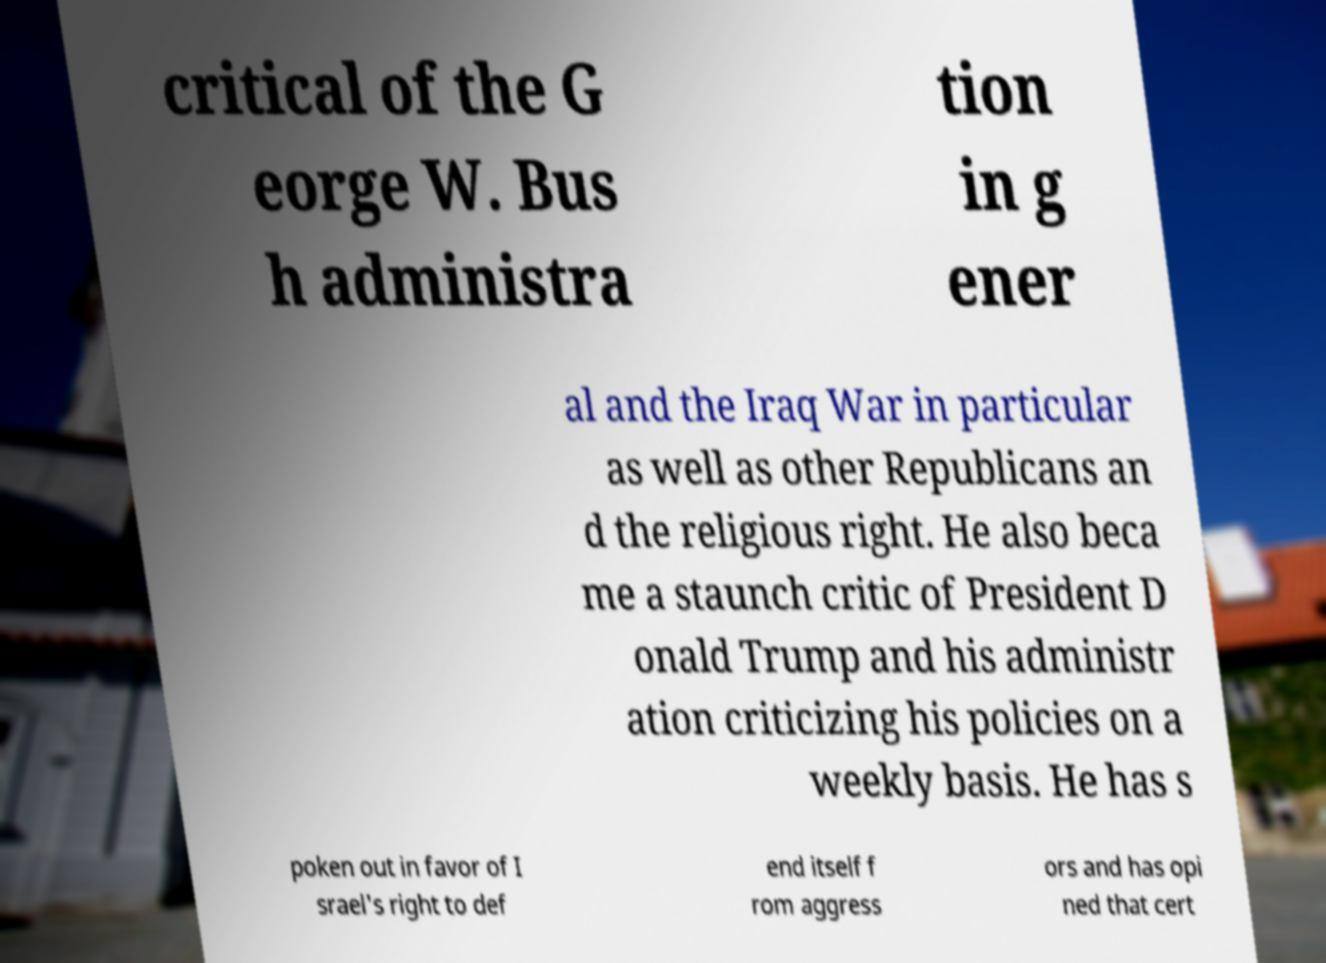Can you accurately transcribe the text from the provided image for me? critical of the G eorge W. Bus h administra tion in g ener al and the Iraq War in particular as well as other Republicans an d the religious right. He also beca me a staunch critic of President D onald Trump and his administr ation criticizing his policies on a weekly basis. He has s poken out in favor of I srael's right to def end itself f rom aggress ors and has opi ned that cert 